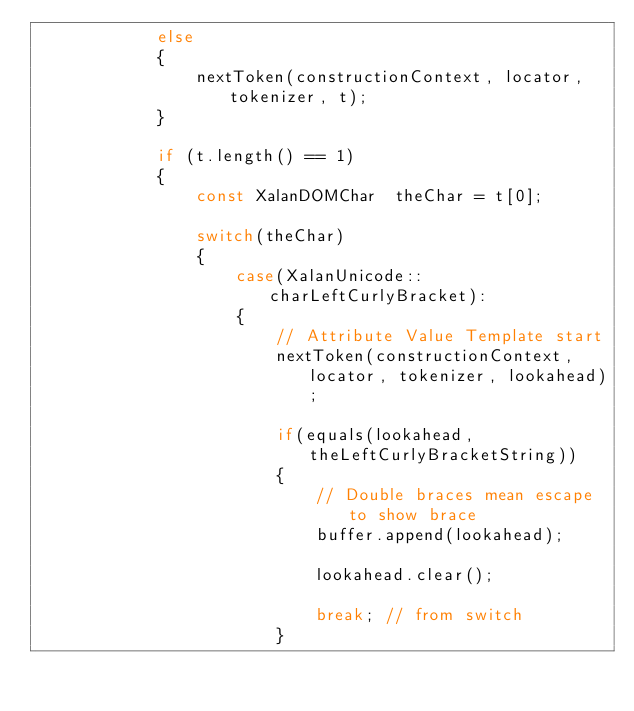<code> <loc_0><loc_0><loc_500><loc_500><_C++_>            else
            {
                nextToken(constructionContext, locator, tokenizer, t);
            }

            if (t.length() == 1)
            {
                const XalanDOMChar  theChar = t[0];

                switch(theChar)
                {
                    case(XalanUnicode::charLeftCurlyBracket):
                    {
                        // Attribute Value Template start
                        nextToken(constructionContext, locator, tokenizer, lookahead);

                        if(equals(lookahead, theLeftCurlyBracketString))
                        {
                            // Double braces mean escape to show brace
                            buffer.append(lookahead);

                            lookahead.clear();

                            break; // from switch
                        }</code> 